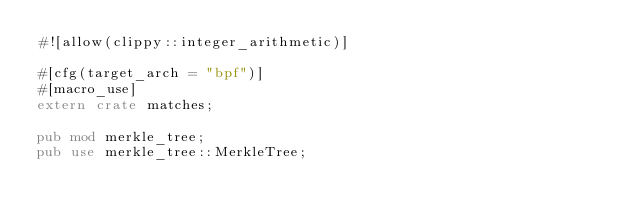Convert code to text. <code><loc_0><loc_0><loc_500><loc_500><_Rust_>#![allow(clippy::integer_arithmetic)]

#[cfg(target_arch = "bpf")]
#[macro_use]
extern crate matches;

pub mod merkle_tree;
pub use merkle_tree::MerkleTree;
</code> 